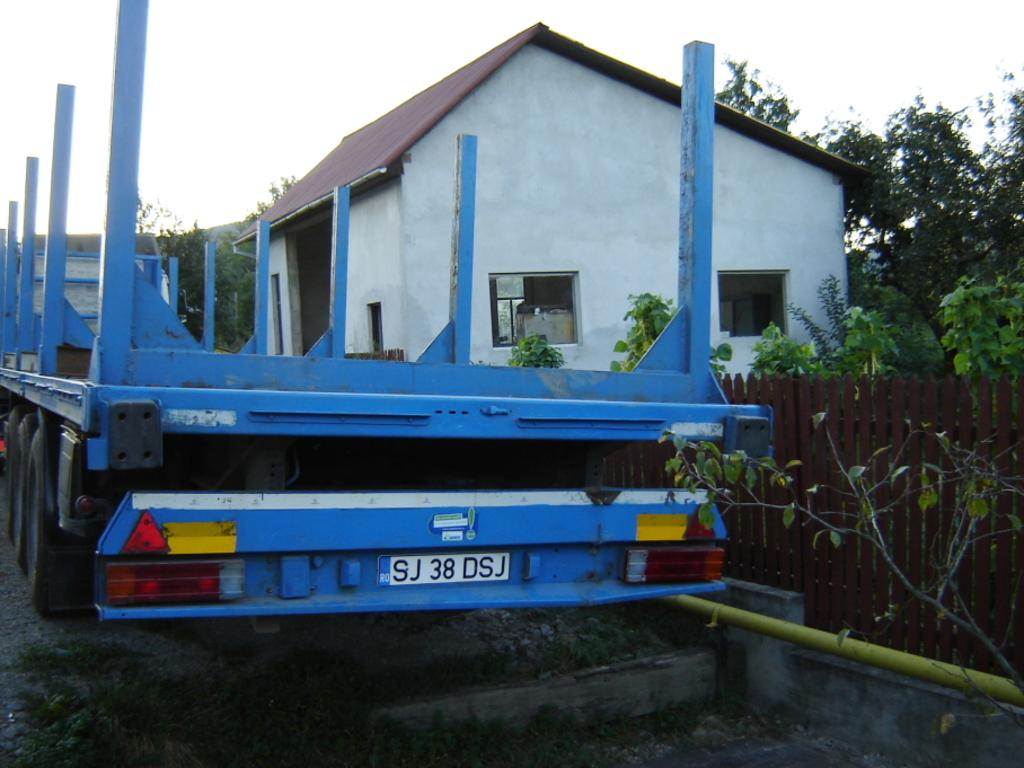What type of vehicle can be seen on the road in the image? There is a blue color vehicle on the road in the image. What structure is present in the image? There is a house in the image. What is the purpose of the barrier in the image? There is a fence in the image, which serves as a barrier or boundary. What type of natural elements can be seen in the image? There are many trees in the image. What is visible in the background of the image? The sky is visible in the image. How many corks are used to adjust the height of the fence in the image? There is no mention of corks or adjustments to the fence in the image; it is simply a barrier or boundary. 